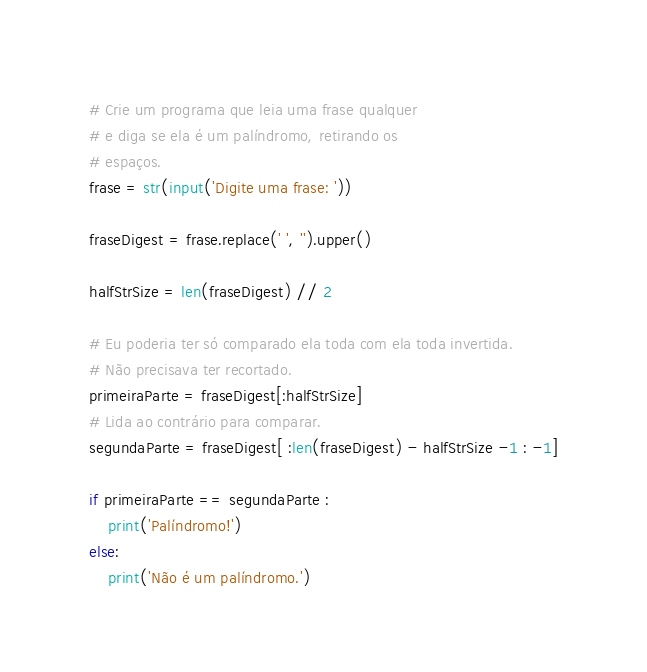Convert code to text. <code><loc_0><loc_0><loc_500><loc_500><_Python_># Crie um programa que leia uma frase qualquer
# e diga se ela é um palíndromo, retirando os
# espaços.
frase = str(input('Digite uma frase: '))

fraseDigest = frase.replace(' ', '').upper()

halfStrSize = len(fraseDigest) // 2

# Eu poderia ter só comparado ela toda com ela toda invertida.
# Não precisava ter recortado.
primeiraParte = fraseDigest[:halfStrSize]
# Lida ao contrário para comparar.
segundaParte = fraseDigest[ :len(fraseDigest) - halfStrSize -1 : -1]

if primeiraParte == segundaParte :
	print('Palíndromo!')
else:
	print('Não é um palíndromo.')
</code> 